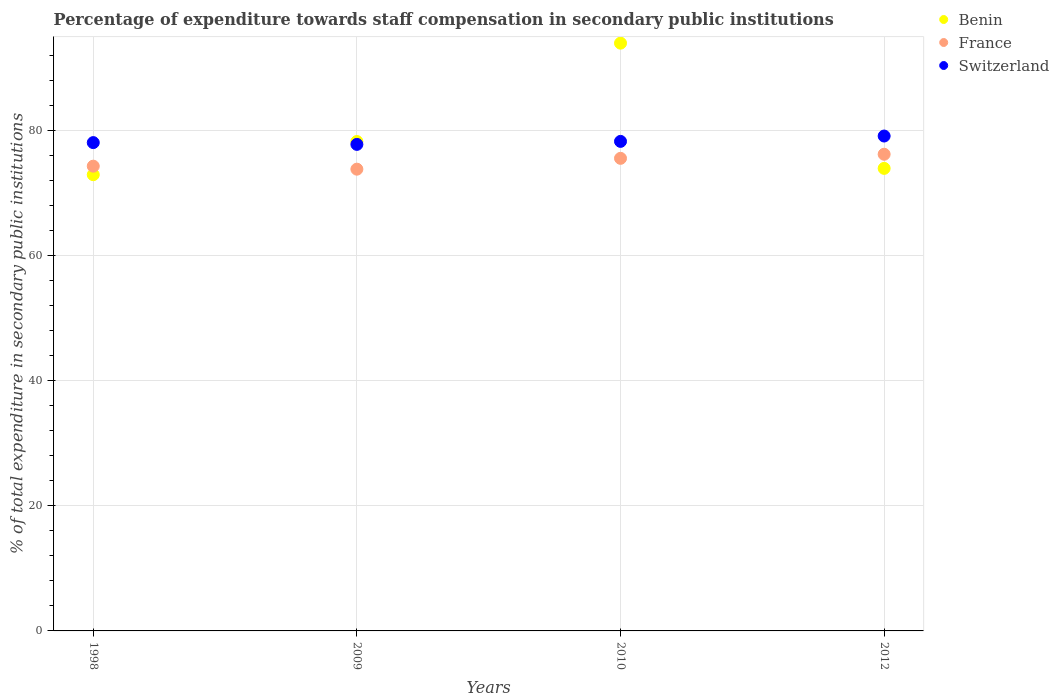Is the number of dotlines equal to the number of legend labels?
Provide a short and direct response. Yes. What is the percentage of expenditure towards staff compensation in Switzerland in 2012?
Offer a very short reply. 79.07. Across all years, what is the maximum percentage of expenditure towards staff compensation in Switzerland?
Keep it short and to the point. 79.07. Across all years, what is the minimum percentage of expenditure towards staff compensation in France?
Your answer should be compact. 73.78. In which year was the percentage of expenditure towards staff compensation in Benin maximum?
Offer a very short reply. 2010. In which year was the percentage of expenditure towards staff compensation in Switzerland minimum?
Ensure brevity in your answer.  2009. What is the total percentage of expenditure towards staff compensation in France in the graph?
Make the answer very short. 299.71. What is the difference between the percentage of expenditure towards staff compensation in Benin in 1998 and that in 2012?
Make the answer very short. -1.01. What is the difference between the percentage of expenditure towards staff compensation in Benin in 2010 and the percentage of expenditure towards staff compensation in Switzerland in 2009?
Your answer should be very brief. 16.18. What is the average percentage of expenditure towards staff compensation in Switzerland per year?
Provide a short and direct response. 78.26. In the year 2010, what is the difference between the percentage of expenditure towards staff compensation in Benin and percentage of expenditure towards staff compensation in Switzerland?
Offer a very short reply. 15.7. What is the ratio of the percentage of expenditure towards staff compensation in Switzerland in 1998 to that in 2010?
Your answer should be very brief. 1. What is the difference between the highest and the second highest percentage of expenditure towards staff compensation in Switzerland?
Provide a succinct answer. 0.86. What is the difference between the highest and the lowest percentage of expenditure towards staff compensation in Benin?
Give a very brief answer. 21.02. Is the percentage of expenditure towards staff compensation in France strictly greater than the percentage of expenditure towards staff compensation in Benin over the years?
Ensure brevity in your answer.  No. Is the percentage of expenditure towards staff compensation in Benin strictly less than the percentage of expenditure towards staff compensation in Switzerland over the years?
Provide a short and direct response. No. How many years are there in the graph?
Provide a short and direct response. 4. Does the graph contain any zero values?
Your response must be concise. No. Does the graph contain grids?
Provide a succinct answer. Yes. Where does the legend appear in the graph?
Give a very brief answer. Top right. What is the title of the graph?
Your answer should be compact. Percentage of expenditure towards staff compensation in secondary public institutions. What is the label or title of the Y-axis?
Your answer should be very brief. % of total expenditure in secondary public institutions. What is the % of total expenditure in secondary public institutions in Benin in 1998?
Keep it short and to the point. 72.9. What is the % of total expenditure in secondary public institutions in France in 1998?
Offer a terse response. 74.26. What is the % of total expenditure in secondary public institutions of Switzerland in 1998?
Ensure brevity in your answer.  78.02. What is the % of total expenditure in secondary public institutions in Benin in 2009?
Give a very brief answer. 78.2. What is the % of total expenditure in secondary public institutions in France in 2009?
Provide a short and direct response. 73.78. What is the % of total expenditure in secondary public institutions of Switzerland in 2009?
Ensure brevity in your answer.  77.74. What is the % of total expenditure in secondary public institutions of Benin in 2010?
Offer a very short reply. 93.91. What is the % of total expenditure in secondary public institutions in France in 2010?
Ensure brevity in your answer.  75.51. What is the % of total expenditure in secondary public institutions in Switzerland in 2010?
Offer a very short reply. 78.22. What is the % of total expenditure in secondary public institutions of Benin in 2012?
Offer a terse response. 73.91. What is the % of total expenditure in secondary public institutions in France in 2012?
Offer a very short reply. 76.16. What is the % of total expenditure in secondary public institutions in Switzerland in 2012?
Offer a very short reply. 79.07. Across all years, what is the maximum % of total expenditure in secondary public institutions of Benin?
Make the answer very short. 93.91. Across all years, what is the maximum % of total expenditure in secondary public institutions of France?
Your answer should be compact. 76.16. Across all years, what is the maximum % of total expenditure in secondary public institutions of Switzerland?
Your answer should be compact. 79.07. Across all years, what is the minimum % of total expenditure in secondary public institutions of Benin?
Your answer should be compact. 72.9. Across all years, what is the minimum % of total expenditure in secondary public institutions of France?
Keep it short and to the point. 73.78. Across all years, what is the minimum % of total expenditure in secondary public institutions of Switzerland?
Give a very brief answer. 77.74. What is the total % of total expenditure in secondary public institutions of Benin in the graph?
Keep it short and to the point. 318.91. What is the total % of total expenditure in secondary public institutions of France in the graph?
Offer a very short reply. 299.71. What is the total % of total expenditure in secondary public institutions in Switzerland in the graph?
Provide a succinct answer. 313.05. What is the difference between the % of total expenditure in secondary public institutions of Benin in 1998 and that in 2009?
Provide a short and direct response. -5.3. What is the difference between the % of total expenditure in secondary public institutions in France in 1998 and that in 2009?
Provide a succinct answer. 0.48. What is the difference between the % of total expenditure in secondary public institutions of Switzerland in 1998 and that in 2009?
Ensure brevity in your answer.  0.29. What is the difference between the % of total expenditure in secondary public institutions in Benin in 1998 and that in 2010?
Keep it short and to the point. -21.02. What is the difference between the % of total expenditure in secondary public institutions of France in 1998 and that in 2010?
Offer a very short reply. -1.25. What is the difference between the % of total expenditure in secondary public institutions of Switzerland in 1998 and that in 2010?
Your response must be concise. -0.19. What is the difference between the % of total expenditure in secondary public institutions in Benin in 1998 and that in 2012?
Ensure brevity in your answer.  -1.01. What is the difference between the % of total expenditure in secondary public institutions in France in 1998 and that in 2012?
Offer a very short reply. -1.9. What is the difference between the % of total expenditure in secondary public institutions in Switzerland in 1998 and that in 2012?
Your answer should be very brief. -1.05. What is the difference between the % of total expenditure in secondary public institutions in Benin in 2009 and that in 2010?
Your response must be concise. -15.72. What is the difference between the % of total expenditure in secondary public institutions of France in 2009 and that in 2010?
Your response must be concise. -1.73. What is the difference between the % of total expenditure in secondary public institutions in Switzerland in 2009 and that in 2010?
Make the answer very short. -0.48. What is the difference between the % of total expenditure in secondary public institutions in Benin in 2009 and that in 2012?
Your response must be concise. 4.29. What is the difference between the % of total expenditure in secondary public institutions of France in 2009 and that in 2012?
Keep it short and to the point. -2.38. What is the difference between the % of total expenditure in secondary public institutions of Switzerland in 2009 and that in 2012?
Offer a terse response. -1.34. What is the difference between the % of total expenditure in secondary public institutions of Benin in 2010 and that in 2012?
Your response must be concise. 20.01. What is the difference between the % of total expenditure in secondary public institutions of France in 2010 and that in 2012?
Your answer should be compact. -0.65. What is the difference between the % of total expenditure in secondary public institutions of Switzerland in 2010 and that in 2012?
Ensure brevity in your answer.  -0.86. What is the difference between the % of total expenditure in secondary public institutions of Benin in 1998 and the % of total expenditure in secondary public institutions of France in 2009?
Provide a short and direct response. -0.88. What is the difference between the % of total expenditure in secondary public institutions in Benin in 1998 and the % of total expenditure in secondary public institutions in Switzerland in 2009?
Provide a succinct answer. -4.84. What is the difference between the % of total expenditure in secondary public institutions of France in 1998 and the % of total expenditure in secondary public institutions of Switzerland in 2009?
Provide a short and direct response. -3.48. What is the difference between the % of total expenditure in secondary public institutions in Benin in 1998 and the % of total expenditure in secondary public institutions in France in 2010?
Make the answer very short. -2.61. What is the difference between the % of total expenditure in secondary public institutions in Benin in 1998 and the % of total expenditure in secondary public institutions in Switzerland in 2010?
Offer a very short reply. -5.32. What is the difference between the % of total expenditure in secondary public institutions of France in 1998 and the % of total expenditure in secondary public institutions of Switzerland in 2010?
Your answer should be very brief. -3.96. What is the difference between the % of total expenditure in secondary public institutions in Benin in 1998 and the % of total expenditure in secondary public institutions in France in 2012?
Your answer should be compact. -3.27. What is the difference between the % of total expenditure in secondary public institutions of Benin in 1998 and the % of total expenditure in secondary public institutions of Switzerland in 2012?
Ensure brevity in your answer.  -6.18. What is the difference between the % of total expenditure in secondary public institutions in France in 1998 and the % of total expenditure in secondary public institutions in Switzerland in 2012?
Keep it short and to the point. -4.82. What is the difference between the % of total expenditure in secondary public institutions of Benin in 2009 and the % of total expenditure in secondary public institutions of France in 2010?
Give a very brief answer. 2.69. What is the difference between the % of total expenditure in secondary public institutions in Benin in 2009 and the % of total expenditure in secondary public institutions in Switzerland in 2010?
Your answer should be compact. -0.02. What is the difference between the % of total expenditure in secondary public institutions in France in 2009 and the % of total expenditure in secondary public institutions in Switzerland in 2010?
Your answer should be compact. -4.44. What is the difference between the % of total expenditure in secondary public institutions in Benin in 2009 and the % of total expenditure in secondary public institutions in France in 2012?
Make the answer very short. 2.04. What is the difference between the % of total expenditure in secondary public institutions of Benin in 2009 and the % of total expenditure in secondary public institutions of Switzerland in 2012?
Give a very brief answer. -0.88. What is the difference between the % of total expenditure in secondary public institutions in France in 2009 and the % of total expenditure in secondary public institutions in Switzerland in 2012?
Offer a very short reply. -5.29. What is the difference between the % of total expenditure in secondary public institutions of Benin in 2010 and the % of total expenditure in secondary public institutions of France in 2012?
Ensure brevity in your answer.  17.75. What is the difference between the % of total expenditure in secondary public institutions of Benin in 2010 and the % of total expenditure in secondary public institutions of Switzerland in 2012?
Keep it short and to the point. 14.84. What is the difference between the % of total expenditure in secondary public institutions in France in 2010 and the % of total expenditure in secondary public institutions in Switzerland in 2012?
Keep it short and to the point. -3.56. What is the average % of total expenditure in secondary public institutions of Benin per year?
Offer a terse response. 79.73. What is the average % of total expenditure in secondary public institutions in France per year?
Make the answer very short. 74.93. What is the average % of total expenditure in secondary public institutions of Switzerland per year?
Your response must be concise. 78.26. In the year 1998, what is the difference between the % of total expenditure in secondary public institutions in Benin and % of total expenditure in secondary public institutions in France?
Give a very brief answer. -1.36. In the year 1998, what is the difference between the % of total expenditure in secondary public institutions in Benin and % of total expenditure in secondary public institutions in Switzerland?
Provide a succinct answer. -5.13. In the year 1998, what is the difference between the % of total expenditure in secondary public institutions in France and % of total expenditure in secondary public institutions in Switzerland?
Offer a very short reply. -3.76. In the year 2009, what is the difference between the % of total expenditure in secondary public institutions of Benin and % of total expenditure in secondary public institutions of France?
Ensure brevity in your answer.  4.42. In the year 2009, what is the difference between the % of total expenditure in secondary public institutions of Benin and % of total expenditure in secondary public institutions of Switzerland?
Provide a short and direct response. 0.46. In the year 2009, what is the difference between the % of total expenditure in secondary public institutions in France and % of total expenditure in secondary public institutions in Switzerland?
Give a very brief answer. -3.96. In the year 2010, what is the difference between the % of total expenditure in secondary public institutions in Benin and % of total expenditure in secondary public institutions in France?
Provide a short and direct response. 18.4. In the year 2010, what is the difference between the % of total expenditure in secondary public institutions in Benin and % of total expenditure in secondary public institutions in Switzerland?
Offer a terse response. 15.7. In the year 2010, what is the difference between the % of total expenditure in secondary public institutions of France and % of total expenditure in secondary public institutions of Switzerland?
Keep it short and to the point. -2.71. In the year 2012, what is the difference between the % of total expenditure in secondary public institutions in Benin and % of total expenditure in secondary public institutions in France?
Keep it short and to the point. -2.26. In the year 2012, what is the difference between the % of total expenditure in secondary public institutions of Benin and % of total expenditure in secondary public institutions of Switzerland?
Provide a succinct answer. -5.17. In the year 2012, what is the difference between the % of total expenditure in secondary public institutions in France and % of total expenditure in secondary public institutions in Switzerland?
Provide a succinct answer. -2.91. What is the ratio of the % of total expenditure in secondary public institutions of Benin in 1998 to that in 2009?
Offer a terse response. 0.93. What is the ratio of the % of total expenditure in secondary public institutions in Benin in 1998 to that in 2010?
Keep it short and to the point. 0.78. What is the ratio of the % of total expenditure in secondary public institutions of France in 1998 to that in 2010?
Keep it short and to the point. 0.98. What is the ratio of the % of total expenditure in secondary public institutions in Switzerland in 1998 to that in 2010?
Your answer should be very brief. 1. What is the ratio of the % of total expenditure in secondary public institutions in Benin in 1998 to that in 2012?
Offer a very short reply. 0.99. What is the ratio of the % of total expenditure in secondary public institutions of Switzerland in 1998 to that in 2012?
Keep it short and to the point. 0.99. What is the ratio of the % of total expenditure in secondary public institutions of Benin in 2009 to that in 2010?
Provide a short and direct response. 0.83. What is the ratio of the % of total expenditure in secondary public institutions of France in 2009 to that in 2010?
Offer a very short reply. 0.98. What is the ratio of the % of total expenditure in secondary public institutions of Switzerland in 2009 to that in 2010?
Provide a succinct answer. 0.99. What is the ratio of the % of total expenditure in secondary public institutions of Benin in 2009 to that in 2012?
Offer a very short reply. 1.06. What is the ratio of the % of total expenditure in secondary public institutions of France in 2009 to that in 2012?
Keep it short and to the point. 0.97. What is the ratio of the % of total expenditure in secondary public institutions of Switzerland in 2009 to that in 2012?
Offer a terse response. 0.98. What is the ratio of the % of total expenditure in secondary public institutions of Benin in 2010 to that in 2012?
Offer a terse response. 1.27. What is the difference between the highest and the second highest % of total expenditure in secondary public institutions in Benin?
Offer a very short reply. 15.72. What is the difference between the highest and the second highest % of total expenditure in secondary public institutions of France?
Offer a terse response. 0.65. What is the difference between the highest and the second highest % of total expenditure in secondary public institutions in Switzerland?
Provide a succinct answer. 0.86. What is the difference between the highest and the lowest % of total expenditure in secondary public institutions in Benin?
Your answer should be very brief. 21.02. What is the difference between the highest and the lowest % of total expenditure in secondary public institutions in France?
Ensure brevity in your answer.  2.38. What is the difference between the highest and the lowest % of total expenditure in secondary public institutions of Switzerland?
Give a very brief answer. 1.34. 